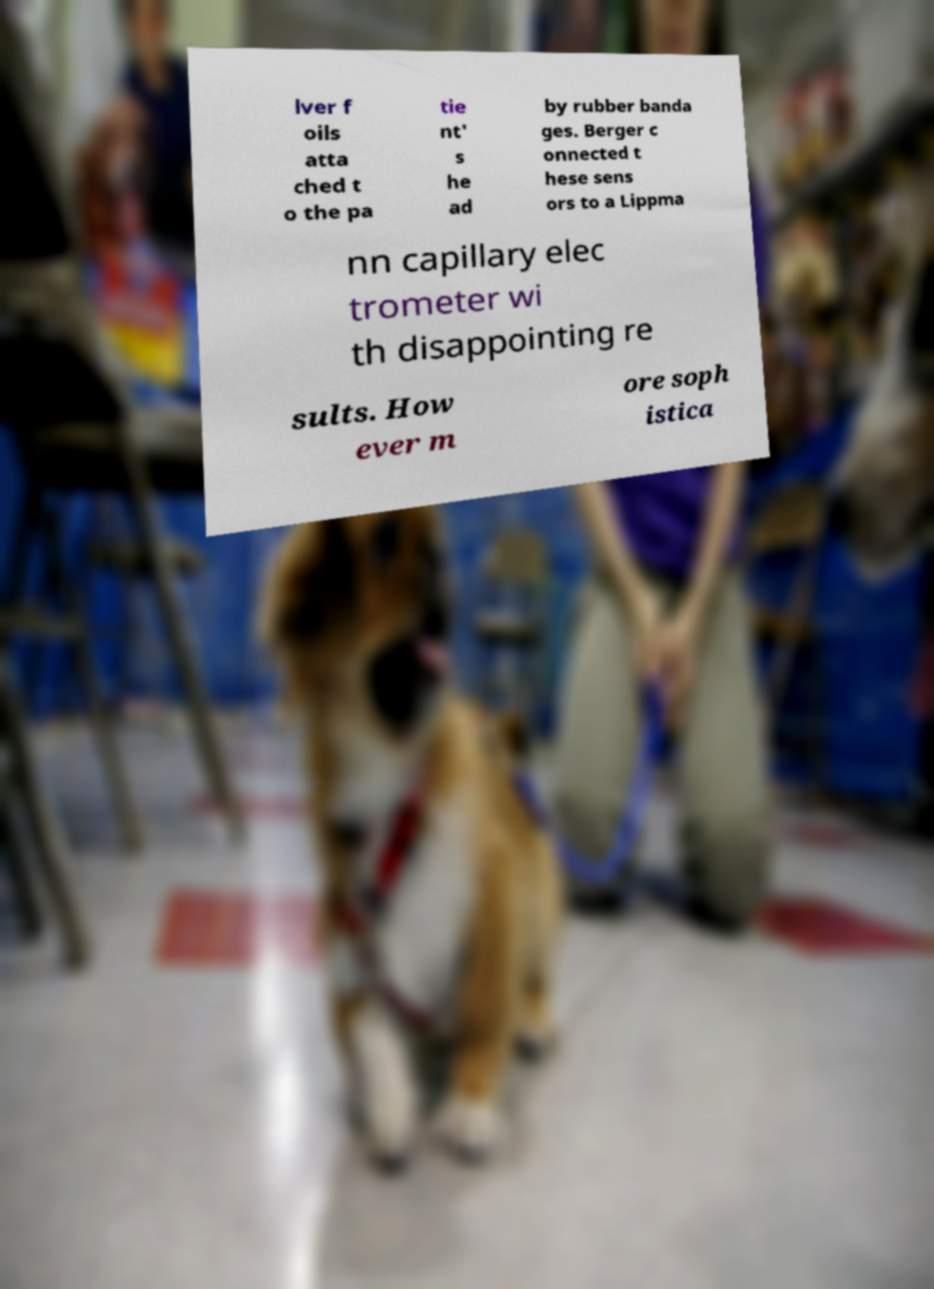What messages or text are displayed in this image? I need them in a readable, typed format. lver f oils atta ched t o the pa tie nt' s he ad by rubber banda ges. Berger c onnected t hese sens ors to a Lippma nn capillary elec trometer wi th disappointing re sults. How ever m ore soph istica 